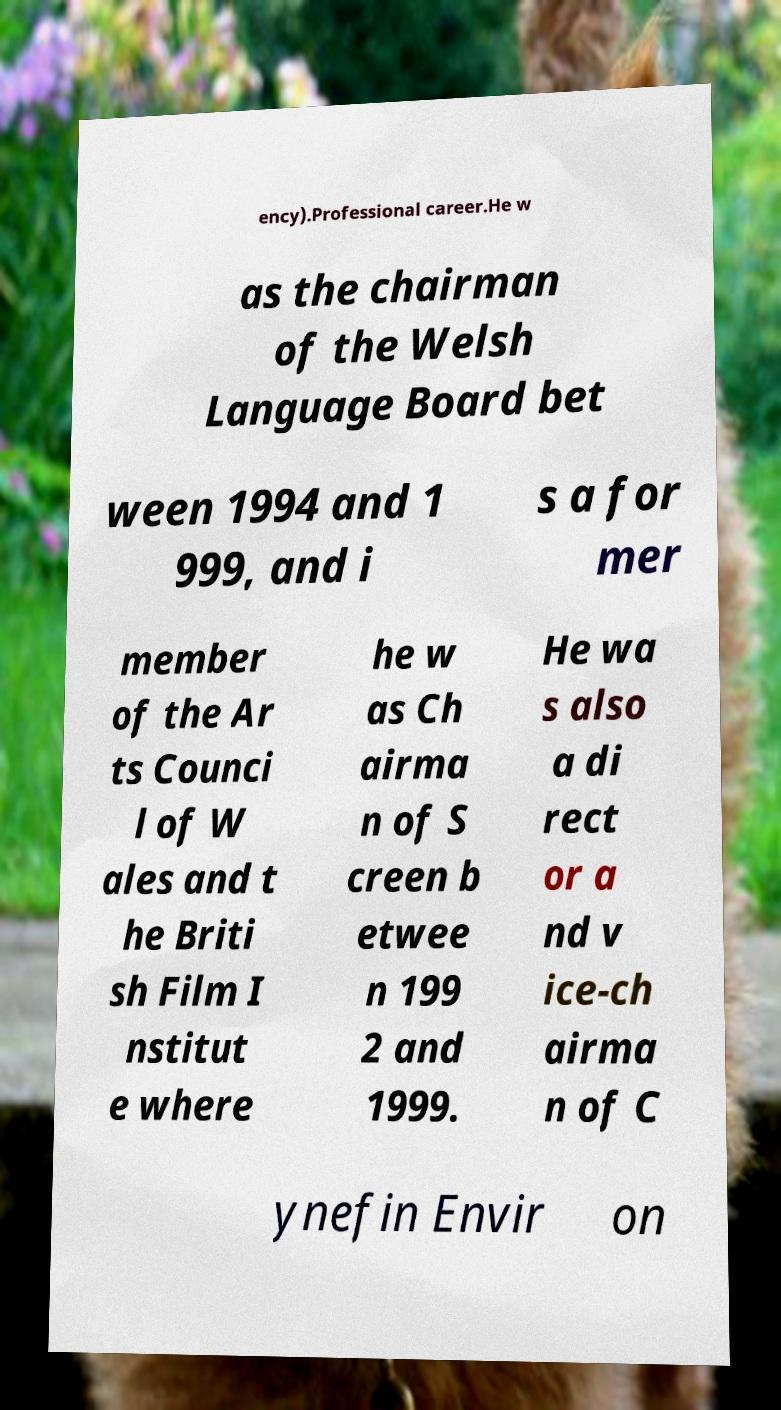Please identify and transcribe the text found in this image. ency).Professional career.He w as the chairman of the Welsh Language Board bet ween 1994 and 1 999, and i s a for mer member of the Ar ts Counci l of W ales and t he Briti sh Film I nstitut e where he w as Ch airma n of S creen b etwee n 199 2 and 1999. He wa s also a di rect or a nd v ice-ch airma n of C ynefin Envir on 